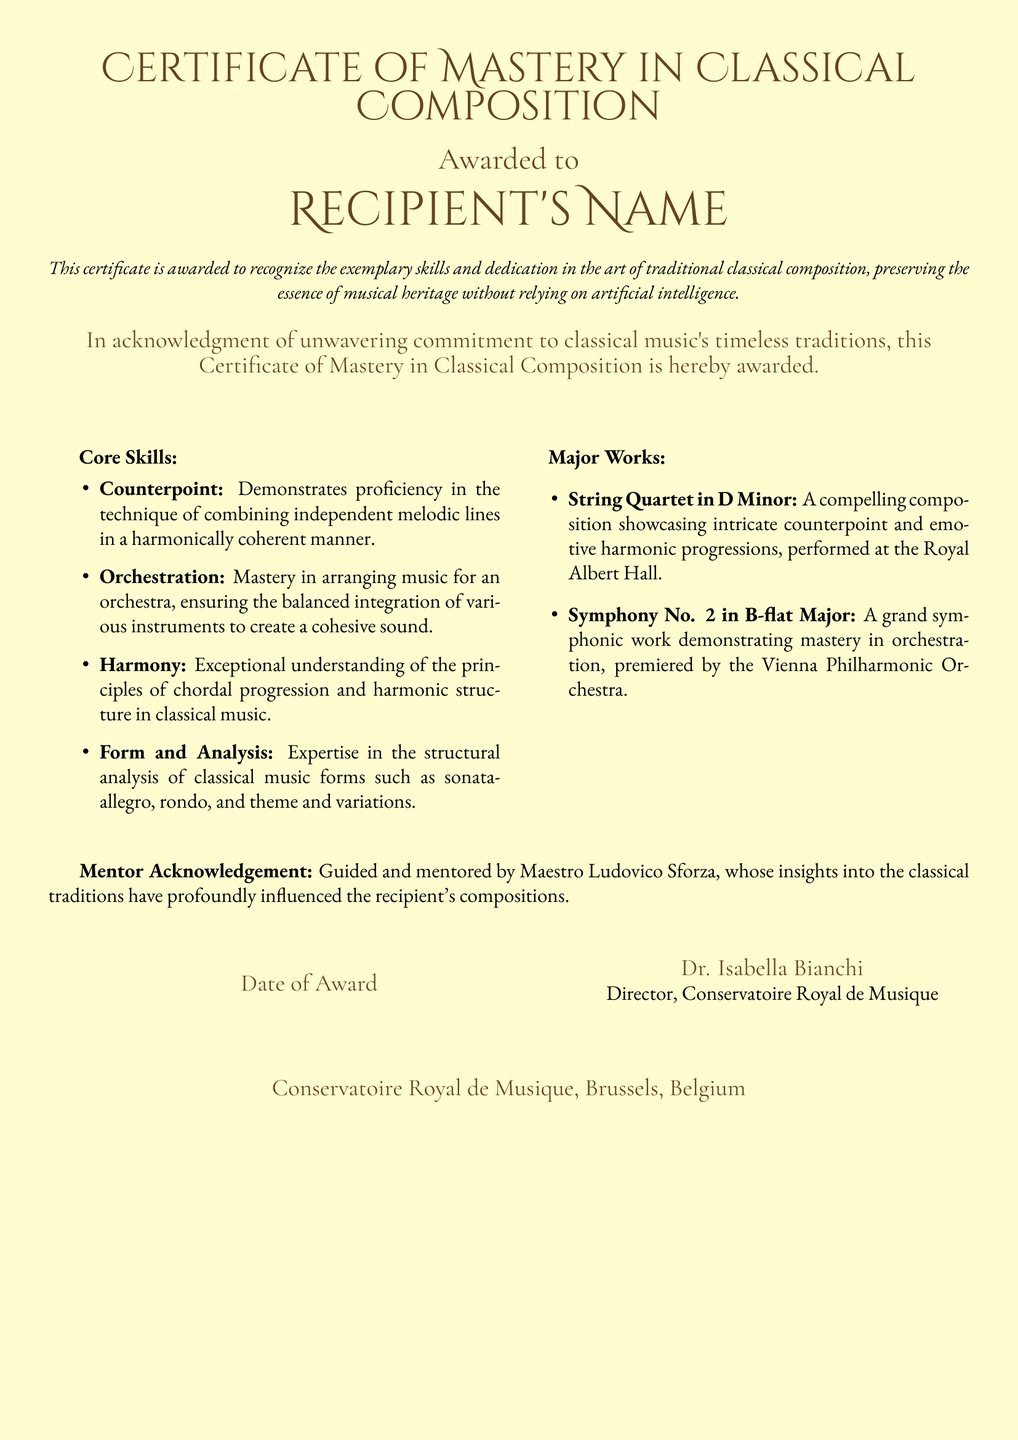What is the title of the certificate? The title of the certificate is presented at the top of the document.
Answer: Certificate of Mastery in Classical Composition Who is the certificate awarded to? The recipient's name is specified in the document where it states "Awarded to."
Answer: Recipient's Name What are the major works listed? The document lists specific compositions as major works in the corresponding section.
Answer: String Quartet in D Minor, Symphony No. 2 in B-flat Major Who is acknowledged as the mentor? The mentor's name is mentioned in the acknowledgment section of the certificate.
Answer: Maestro Ludovico Sforza What is the name of the director? The document provides the name of the director who signed the certificate.
Answer: Dr. Isabella Bianchi What institution issued the certificate? The bottom section of the document states the institution's name in full.
Answer: Conservatoire Royal de Musique, Brussels, Belgium What does the certificate recognize? The document highlights the purpose or significance of the certificate in a specific phrase.
Answer: Exemplary skills and dedication in the art of traditional classical composition What date is indicated for the award? The certificate has a section labeled for the date of the award.
Answer: Date of Award 